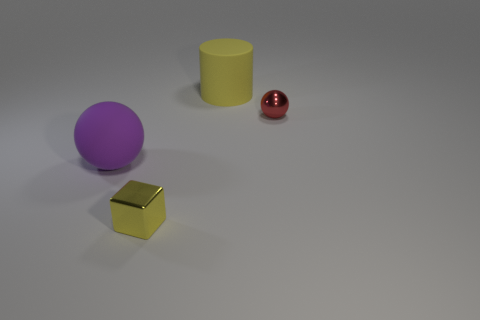Add 2 small red balls. How many objects exist? 6 Subtract 0 blue spheres. How many objects are left? 4 Subtract all cubes. How many objects are left? 3 Subtract all objects. Subtract all tiny blue balls. How many objects are left? 0 Add 4 tiny red shiny balls. How many tiny red shiny balls are left? 5 Add 4 large cyan metallic blocks. How many large cyan metallic blocks exist? 4 